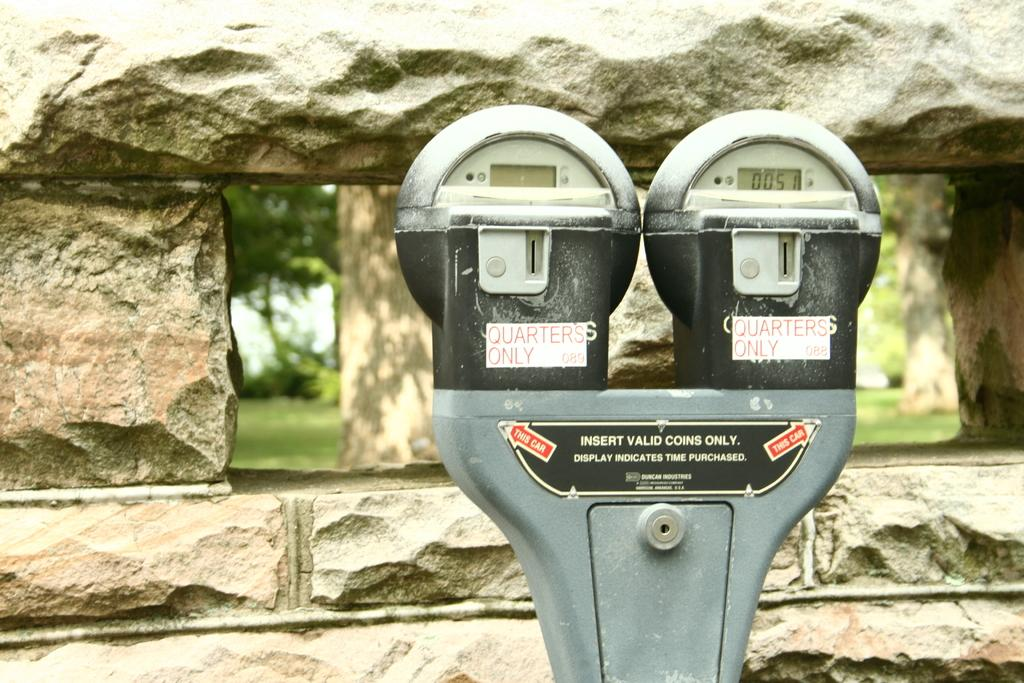<image>
Provide a brief description of the given image. Outdoor double parking meter for quarters only set against a stone wall. 